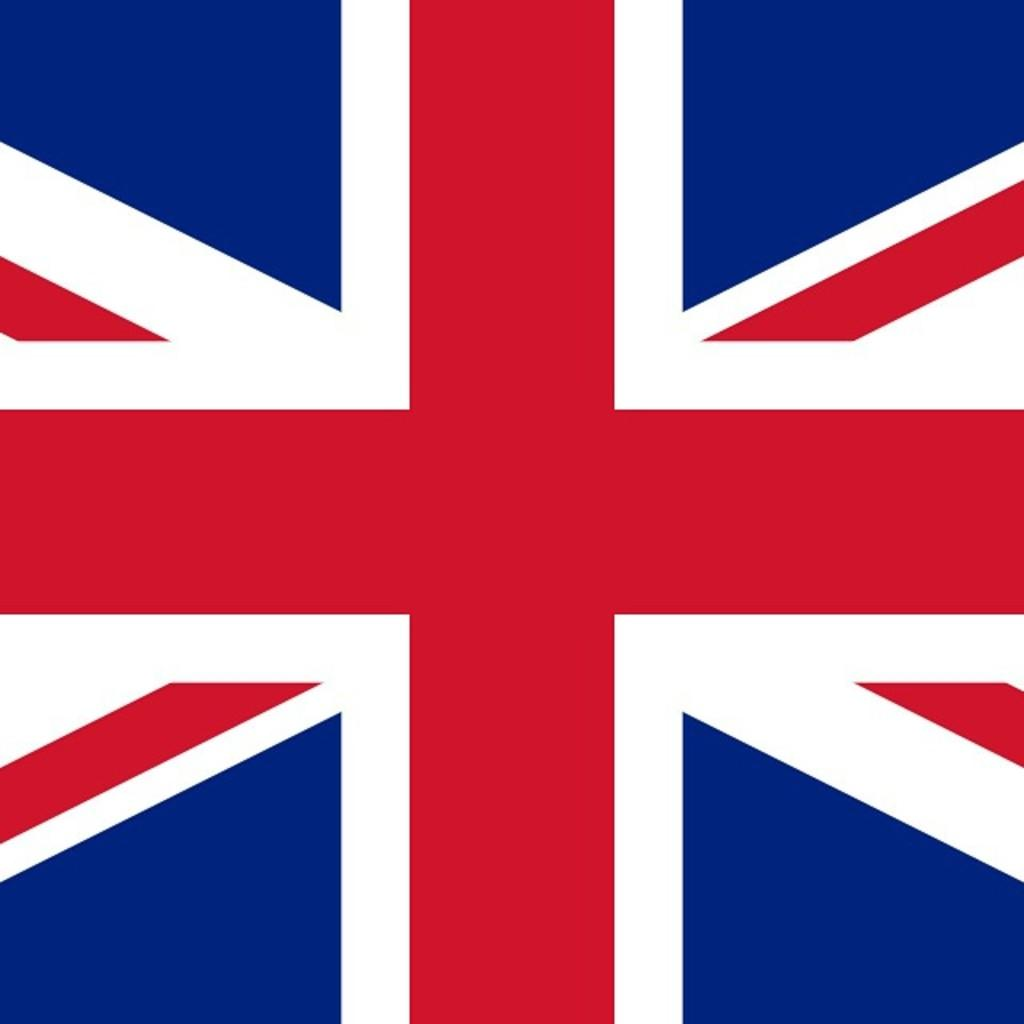What country's flag is depicted in the image? The flag is the British country flag. What colors are present in the flag? The flag has red, white, and blue colors. What type of ink is used to color the steel in the image? There is no ink or steel present in the image; it only features a flag. 